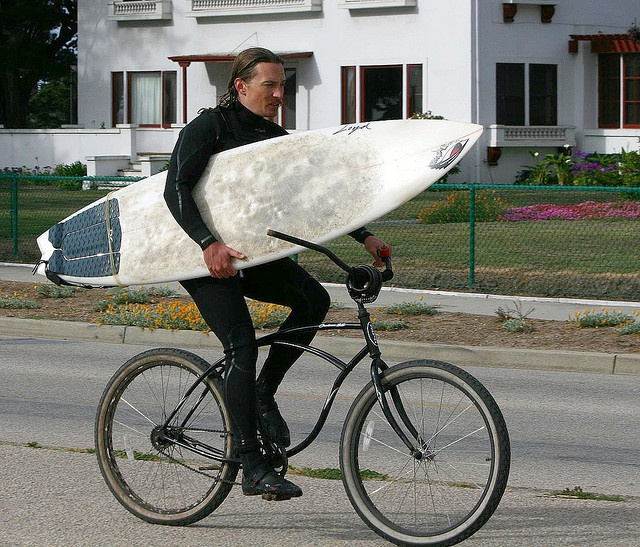Describe the objects in this image and their specific colors. I can see bicycle in black, darkgray, and gray tones, surfboard in black, lightgray, darkgray, and gray tones, and people in black, lightgray, and darkgray tones in this image. 